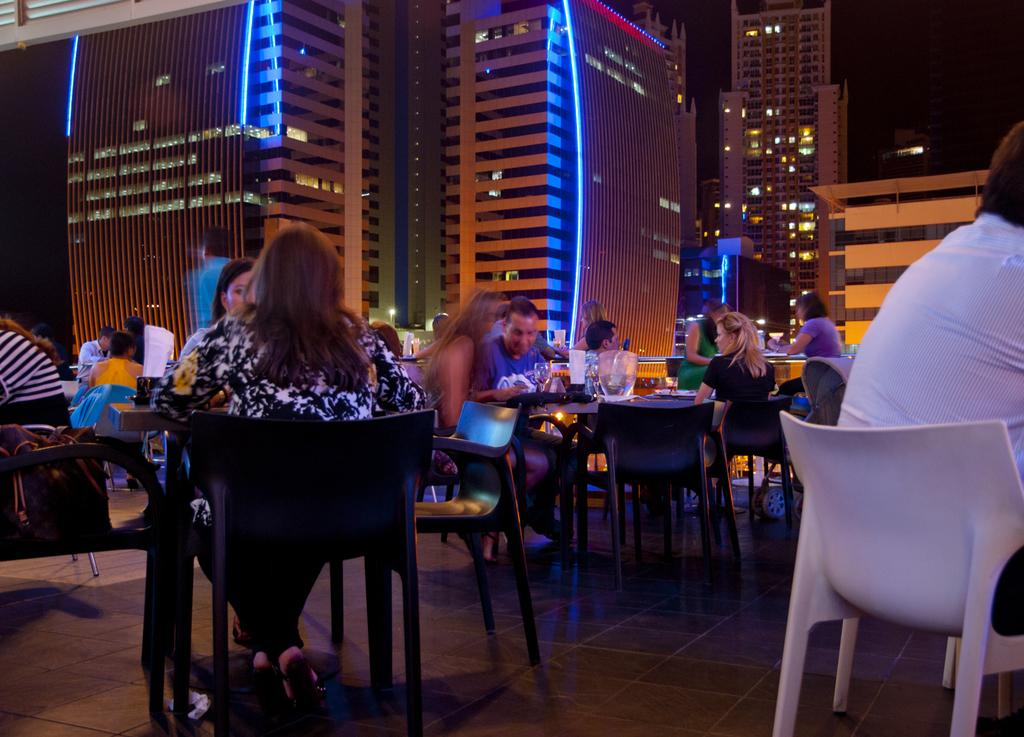What are the people in the image doing? The people in the image are sitting around tables. What is on the tables? There is food on the tables. What activity are the people engaged in? People are speaking in the image. What can be seen in the background of the image? There is a big building in the background of the image. What feature of the building is mentioned? The building has lights. Is there any dirt visible on the tables in the image? There is no mention of dirt in the image, so we cannot determine if it is present or not. 